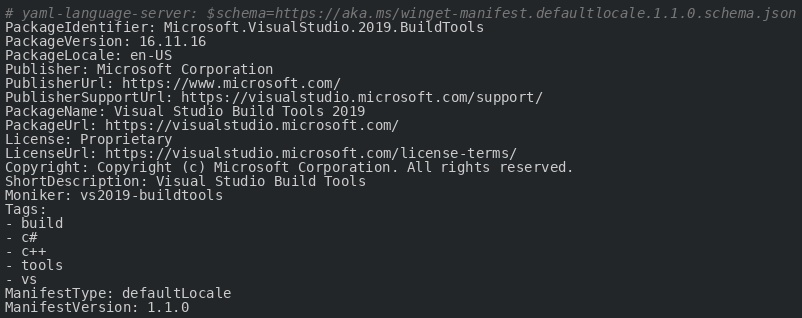Convert code to text. <code><loc_0><loc_0><loc_500><loc_500><_YAML_># yaml-language-server: $schema=https://aka.ms/winget-manifest.defaultlocale.1.1.0.schema.json
PackageIdentifier: Microsoft.VisualStudio.2019.BuildTools
PackageVersion: 16.11.16
PackageLocale: en-US
Publisher: Microsoft Corporation
PublisherUrl: https://www.microsoft.com/
PublisherSupportUrl: https://visualstudio.microsoft.com/support/
PackageName: Visual Studio Build Tools 2019
PackageUrl: https://visualstudio.microsoft.com/
License: Proprietary
LicenseUrl: https://visualstudio.microsoft.com/license-terms/
Copyright: Copyright (c) Microsoft Corporation. All rights reserved.
ShortDescription: Visual Studio Build Tools
Moniker: vs2019-buildtools
Tags:
- build
- c#
- c++
- tools
- vs
ManifestType: defaultLocale
ManifestVersion: 1.1.0

</code> 